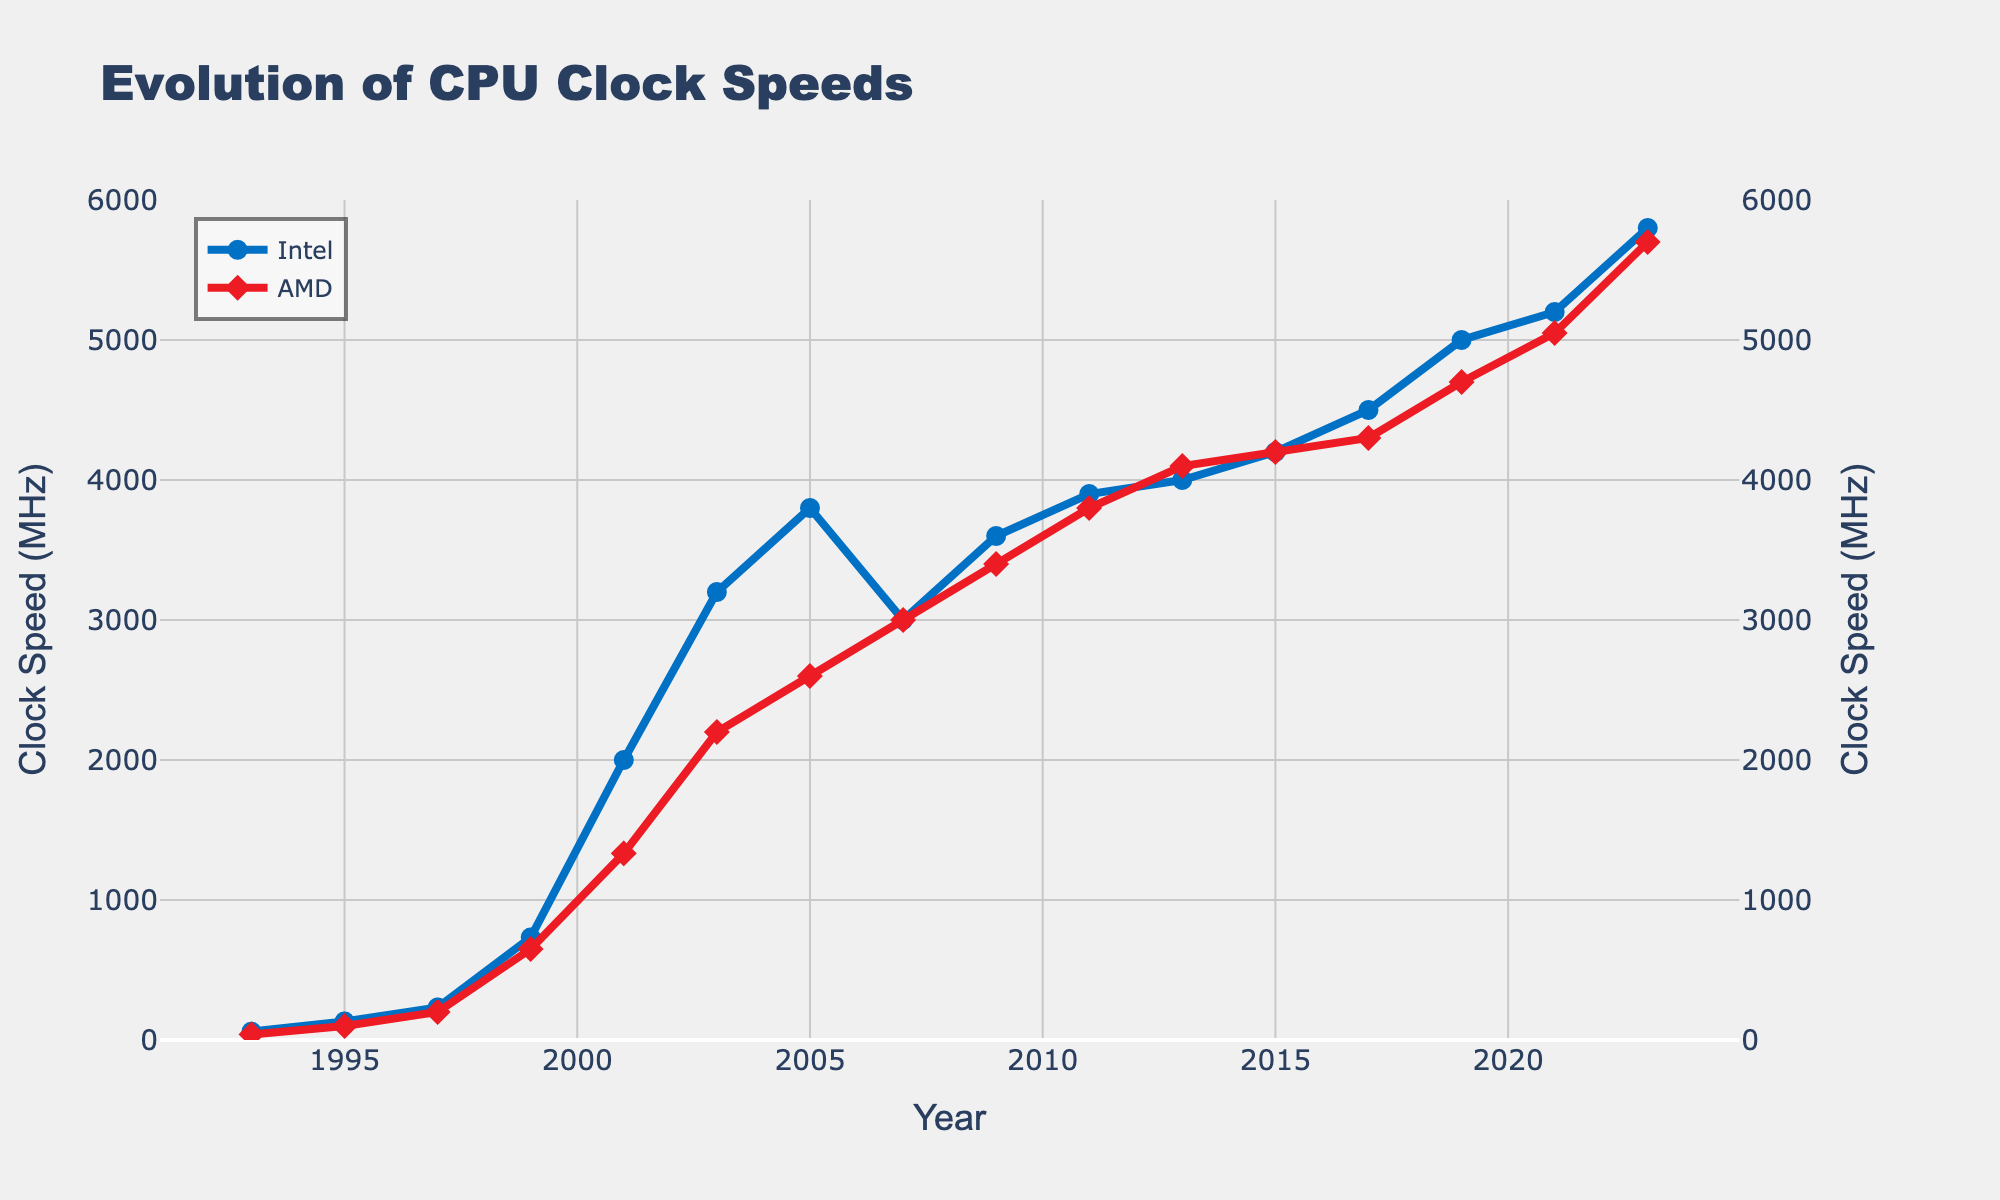What's the highest clock speed attained by Intel processors over the years? To find the highest clock speed, look at the peak value of the Intel line in the chart. The highest point is 5800 MHz in 2023.
Answer: 5800 MHz How does AMD's clock speed in 2001 compare to Intel's in the same year? Check the values for both Intel and AMD in the year 2001. Intel's clock speed is 2000 MHz and AMD's is 1333 MHz. Hence, Intel's clock speed is higher.
Answer: Intel is higher What is the difference in clock speed between Intel and AMD processors in 2019? Subtract AMD's clock speed from Intel's in the year 2019. Intel's clock speed is 5000 MHz and AMD's is 4700 MHz. The difference is 5000 - 4700 = 300 MHz.
Answer: 300 MHz Calculate the average clock speed of Intel processors from 2017 to 2023. First, list the clock speeds for Intel from 2017 to 2023: 4500, 5000, 5200, 5800. Calculate the sum: 4500 + 5000 + 5200 + 5800 = 20500. Divide by the number of years (4): 20500 / 4 = 5125 MHz.
Answer: 5125 MHz Which company showed a faster increase in clock speed from 1995 to 1997? Find the increase from 1995 to 1997 for both companies. Intel: 233 - 133 = 100 MHz. AMD: 200 - 100 = 100 MHz. Both companies showed an equal increase in clock speed.
Answer: Both are equal Are there any years where AMD's clock speed exceeds Intel's? Compare the values of both companies year by year. Only in 2013 does AMD's clock speed (4100 MHz) exceed Intel's (4000 MHz).
Answer: Yes, in 2013 What is the median clock speed for AMD processors between 2001 and 2011? List AMD clock speeds from 2001 to 2011: 1333, 2200, 2600, 3000, 3400, 3800. There are six values; the median is the average of the third and fourth values (2600 and 3000). (2600+3000)/2 = 2800 MHz.
Answer: 2800 MHz In which year did Intel see the greatest single-year increase in clock speed? Find the largest year-over-year increase for Intel by comparing each pair of consecutive years. The largest jump is from 1999 to 2001 (2000 - 733 = 1267 MHz).
Answer: 2001 Compare the trends of Intel and AMD's clock speeds from 2007 to 2015. From 2007 to 2015, Intel's clock speed generally rises from 3000 to 4200 MHz, a steady increase. AMD's clock speed rises from 3000 to 4200 MHz, mirroring Intel but slightly more gradual.
Answer: Similar trend What is the percentage increase in clock speed for AMD from 1993 to 2023? Calculate the percentage increase using the formula [(final - initial) / initial] * 100. Initial value (1993) = 40 MHz, final value (2023) = 5700 MHz. [(5700 - 40) / 40] * 100 = 14150%.
Answer: 14150% 